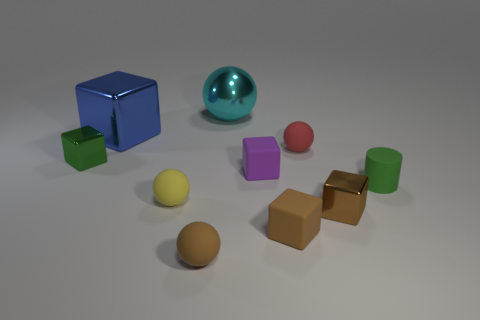Subtract 1 balls. How many balls are left? 3 Subtract all red blocks. Subtract all purple cylinders. How many blocks are left? 5 Subtract all spheres. How many objects are left? 6 Subtract 0 cyan cylinders. How many objects are left? 10 Subtract all big blue cubes. Subtract all small yellow objects. How many objects are left? 8 Add 9 green blocks. How many green blocks are left? 10 Add 2 large cyan rubber spheres. How many large cyan rubber spheres exist? 2 